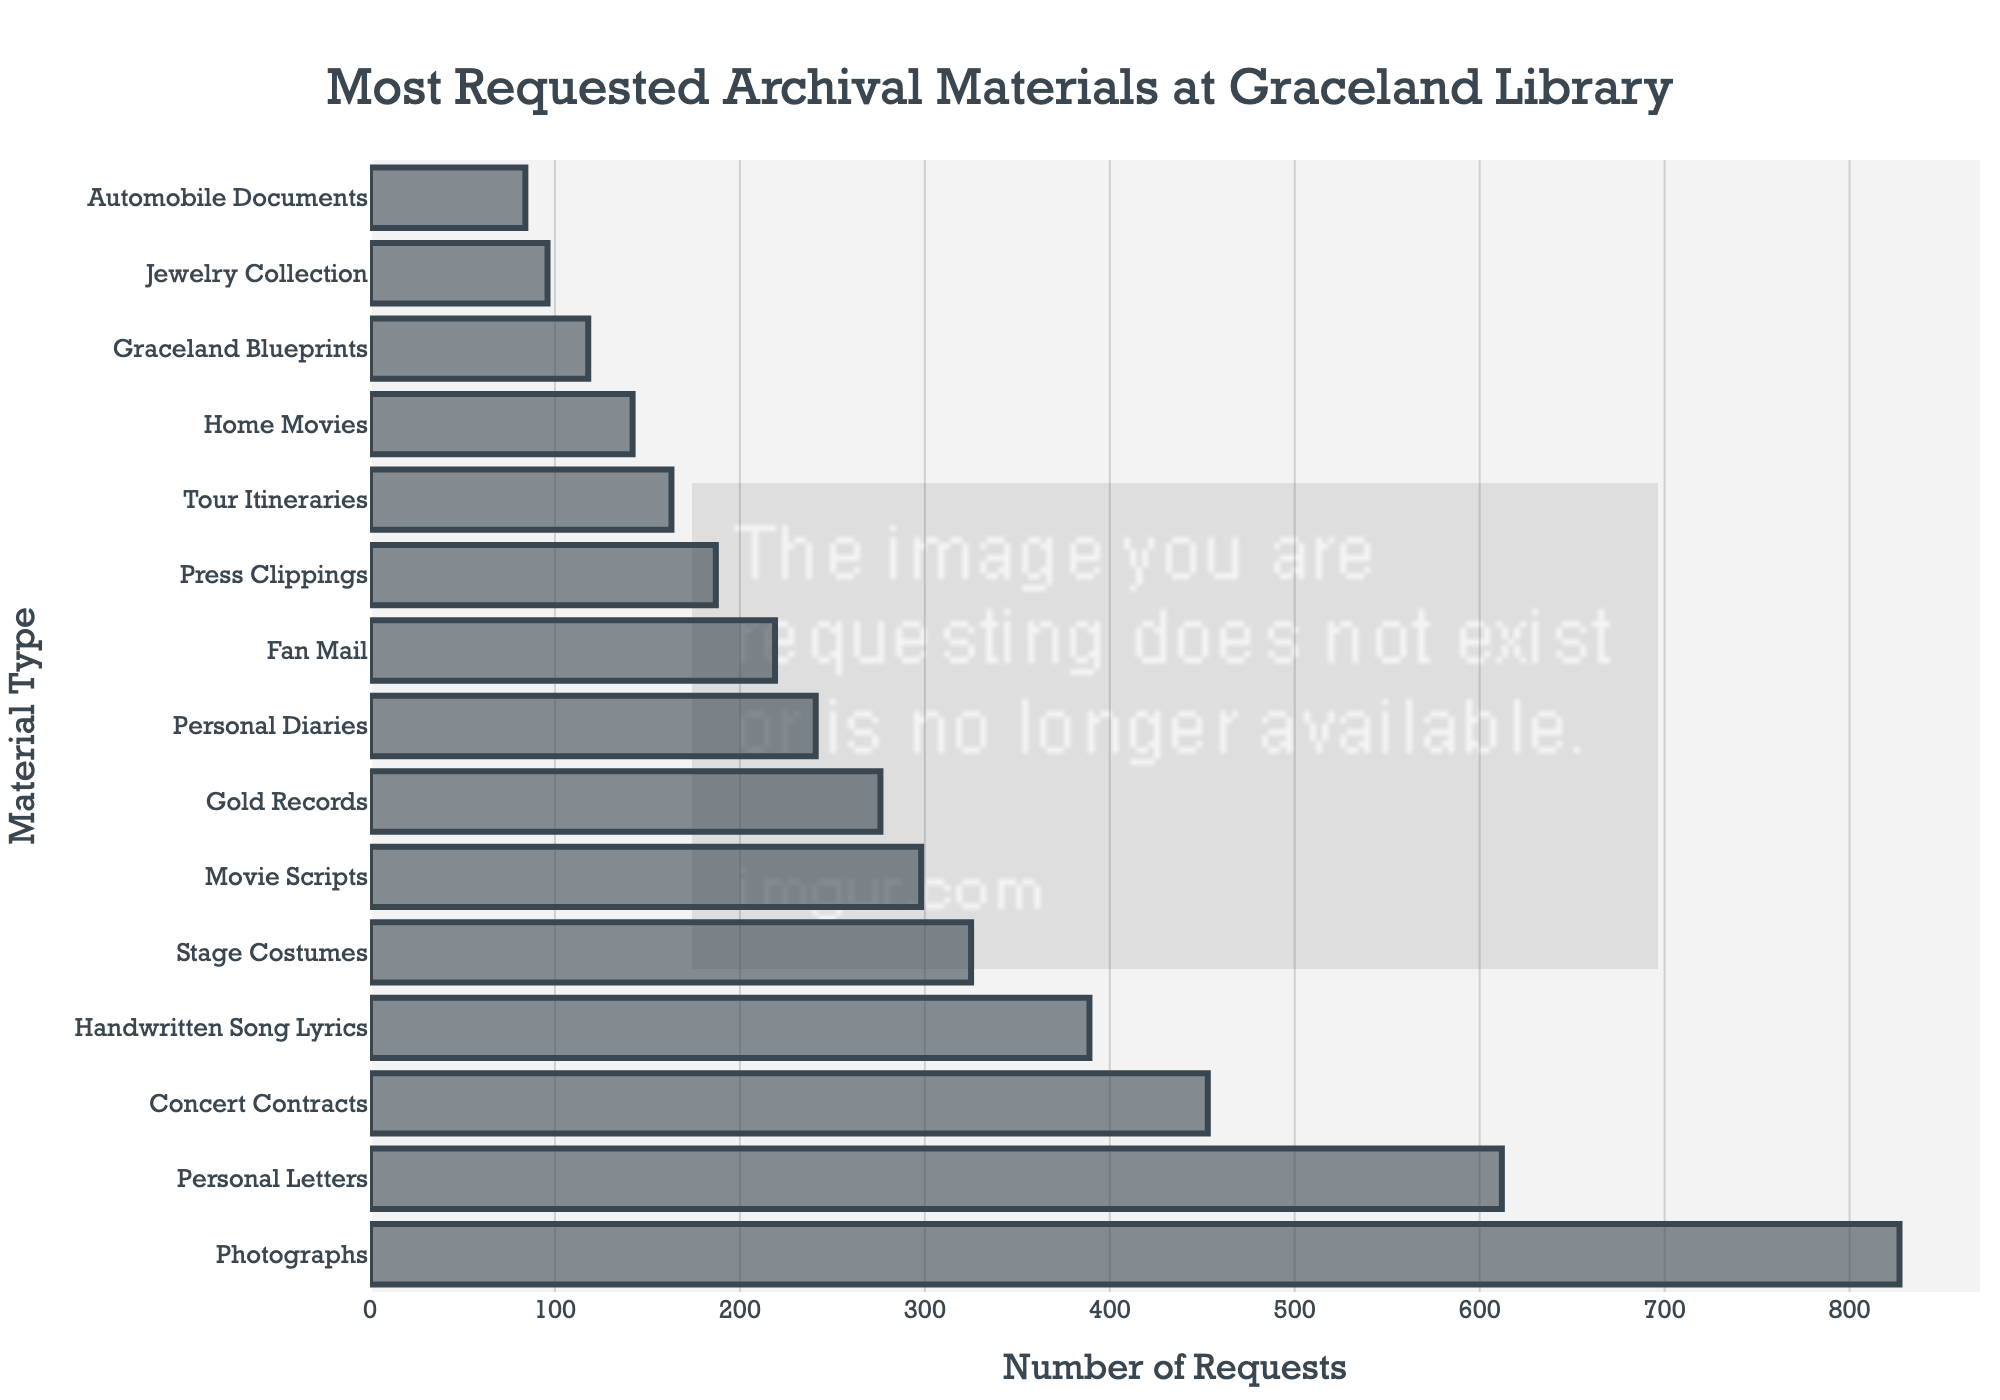Which archival material has the highest number of requests? To find the material with the highest number of requests, locate the tallest bar in the plot. The label next to this bar denotes the material type.
Answer: Photographs Which material has a lower number of requests: Fan Mail or Stage Costumes? Identify the bars corresponding to Fan Mail and Stage Costumes. Compare their heights; the shorter bar indicates the material with fewer requests.
Answer: Fan Mail What is the total number of requests for Home Movies, Graceland Blueprints, and Automobile Documents combined? Sum the numbers shown at the ends of the bars for Home Movies, Graceland Blueprints, and Automobile Documents: 142 + 118 + 84.
Answer: 344 How much higher is the number of requests for Personal Letters compared to Concert Contracts? Determine the number next to each bar: Personal Letters (612) and Concert Contracts (453). Subtract the smaller number from the larger: 612 - 453.
Answer: 159 What is the average number of requests for the categories with fewer than 200 requests? Identify the bars below the 200-request mark: Press Clippings (187), Tour Itineraries (163), Home Movies (142), Graceland Blueprints (118), Jewelry Collection (96), and Automobile Documents (84). Sum these and divide by the count: (187 + 163 + 142 + 118 + 96 + 84) / 6.
Answer: 131.67 Are the requests for Handwritten Song Lyrics greater than the requests for Stage Costumes? Compare the heights or the values next to the bars for Handwritten Song Lyrics (389) and Stage Costumes (325). The higher value indicates the item with more requests.
Answer: Yes What percentage of the total requests do Personal Letters constitute? Add up all the requests to find the total. Personal Letters have 612 requests. Divide 612 by the total sum and multiply by 100 to get the percentage.
Answer: 19% Which material type has more requests: Movie Scripts or Gold Records? Compare the heights or values next to the bars for Movie Scripts (298) and Gold Records (276).
Answer: Movie Scripts 